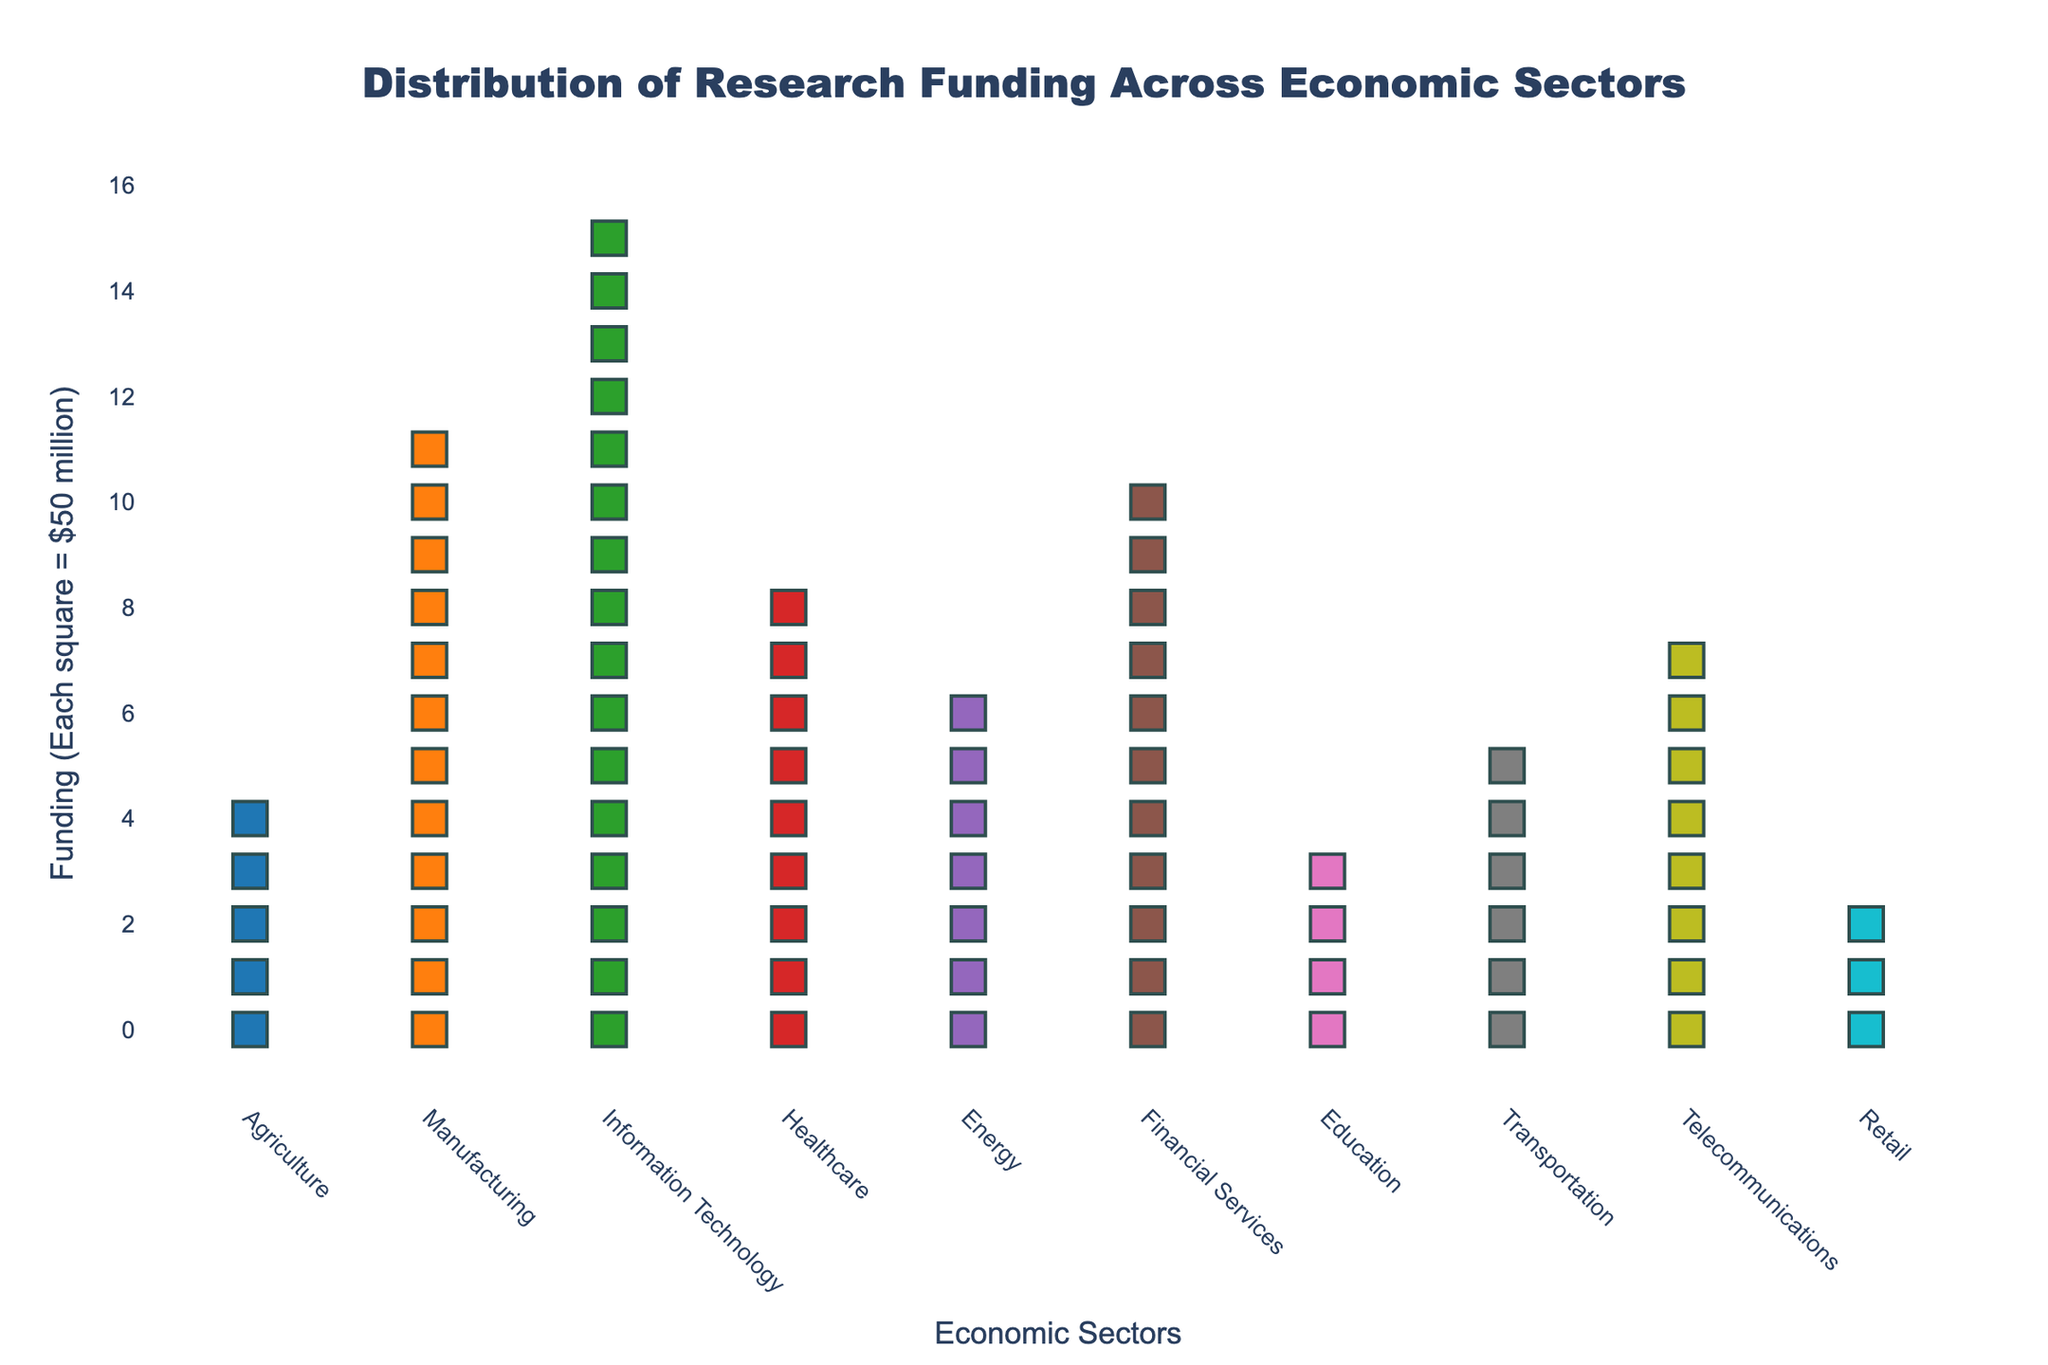What is the title of the figure? The title is located at the top of the figure, centered. It is "Distribution of Research Funding Across Economic Sectors".
Answer: Distribution of Research Funding Across Economic Sectors How many economic sectors are displayed in the figure? The x-axis lists the economic sectors. Counting them gives a total of 10 sectors.
Answer: 10 Which economic sector received the highest funding? The height of the markers in each sector represents the funding. The Information Technology sector has the tallest stack, indicating it received the highest funding.
Answer: Information Technology Which sector received less funding than Healthcare but more than Transportation? Comparing the heights of the markers, Financial Services received more funding than Healthcare (9 markers) and more than Transportation (6 markers), but less than Healthcare (9 markers).
Answer: Financial Services What is the total funding for the sectors? Each square represents $50 million. Summing all the squares: 5 (Agriculture) + 12 (Manufacturing) + 16 (Information Technology) + 9 (Healthcare) + 7 (Energy) + 11 (Financial Services) + 4 (Education) + 6 (Transportation) + 8 (Telecommunications) + 3 (Retail) = 81 squares. Therefore, total funding = 81 * $50 million = $4050 million.
Answer: $4050 million Which sector has twice as much funding as Retail? Retail has 3 squares (3 * $50 million = $150 million). The sector with twice as much would have $300 million, which corresponds to 6 squares. Transportation, which has 6 squares, fits this criterion.
Answer: Transportation What is the funding difference between Energy and Education sectors? Energy has 7 squares (7 * $50 million = $350 million) and Education has 4 squares (4 * $50 million = $200 million). The difference is $350 million - $200 million = $150 million.
Answer: $150 million Which sector's funding is closest to the average funding of all sectors? Average funding = total funding / number of sectors = $4050 million / 10 = $405 million. Healthcare, with 9 squares (9 * $50 million = $450 million), is the closest to $405 million.
Answer: Healthcare How many sectors received funding of $400 million or more? Each square represents $50 million. To have $400 million or more, a sector must have 8 squares or more. The sectors are Manufacturing (12), Information Technology (16), Healthcare (9), Financial Services (11), and Telecommunications (8), which totals to 5 sectors.
Answer: 5 Which sector has the fewest squares, and how many squares does it have? The Retail sector has the fewest squares, with only 3 squares.
Answer: Retail, 3 